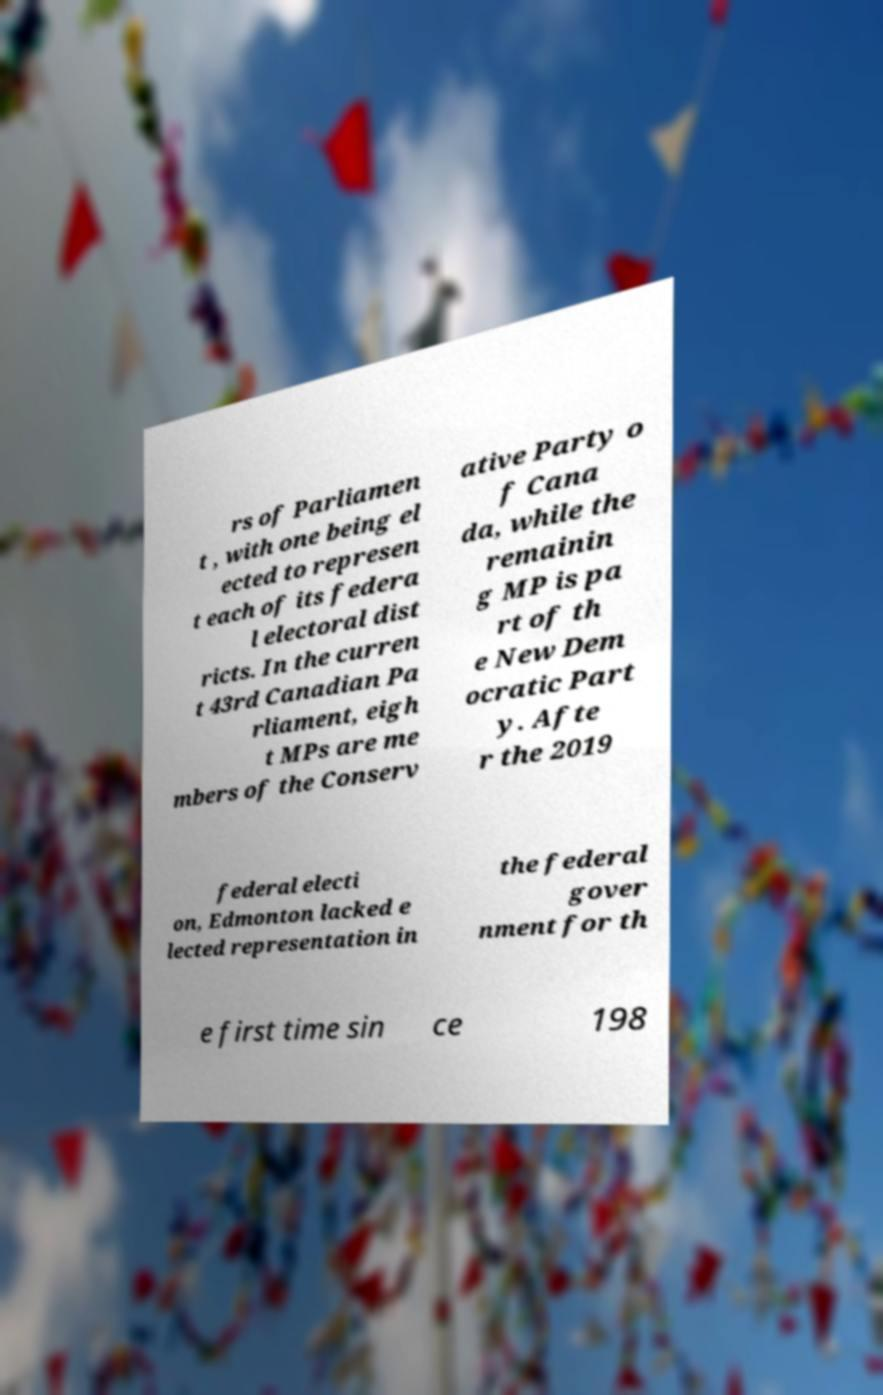For documentation purposes, I need the text within this image transcribed. Could you provide that? rs of Parliamen t , with one being el ected to represen t each of its federa l electoral dist ricts. In the curren t 43rd Canadian Pa rliament, eigh t MPs are me mbers of the Conserv ative Party o f Cana da, while the remainin g MP is pa rt of th e New Dem ocratic Part y. Afte r the 2019 federal electi on, Edmonton lacked e lected representation in the federal gover nment for th e first time sin ce 198 